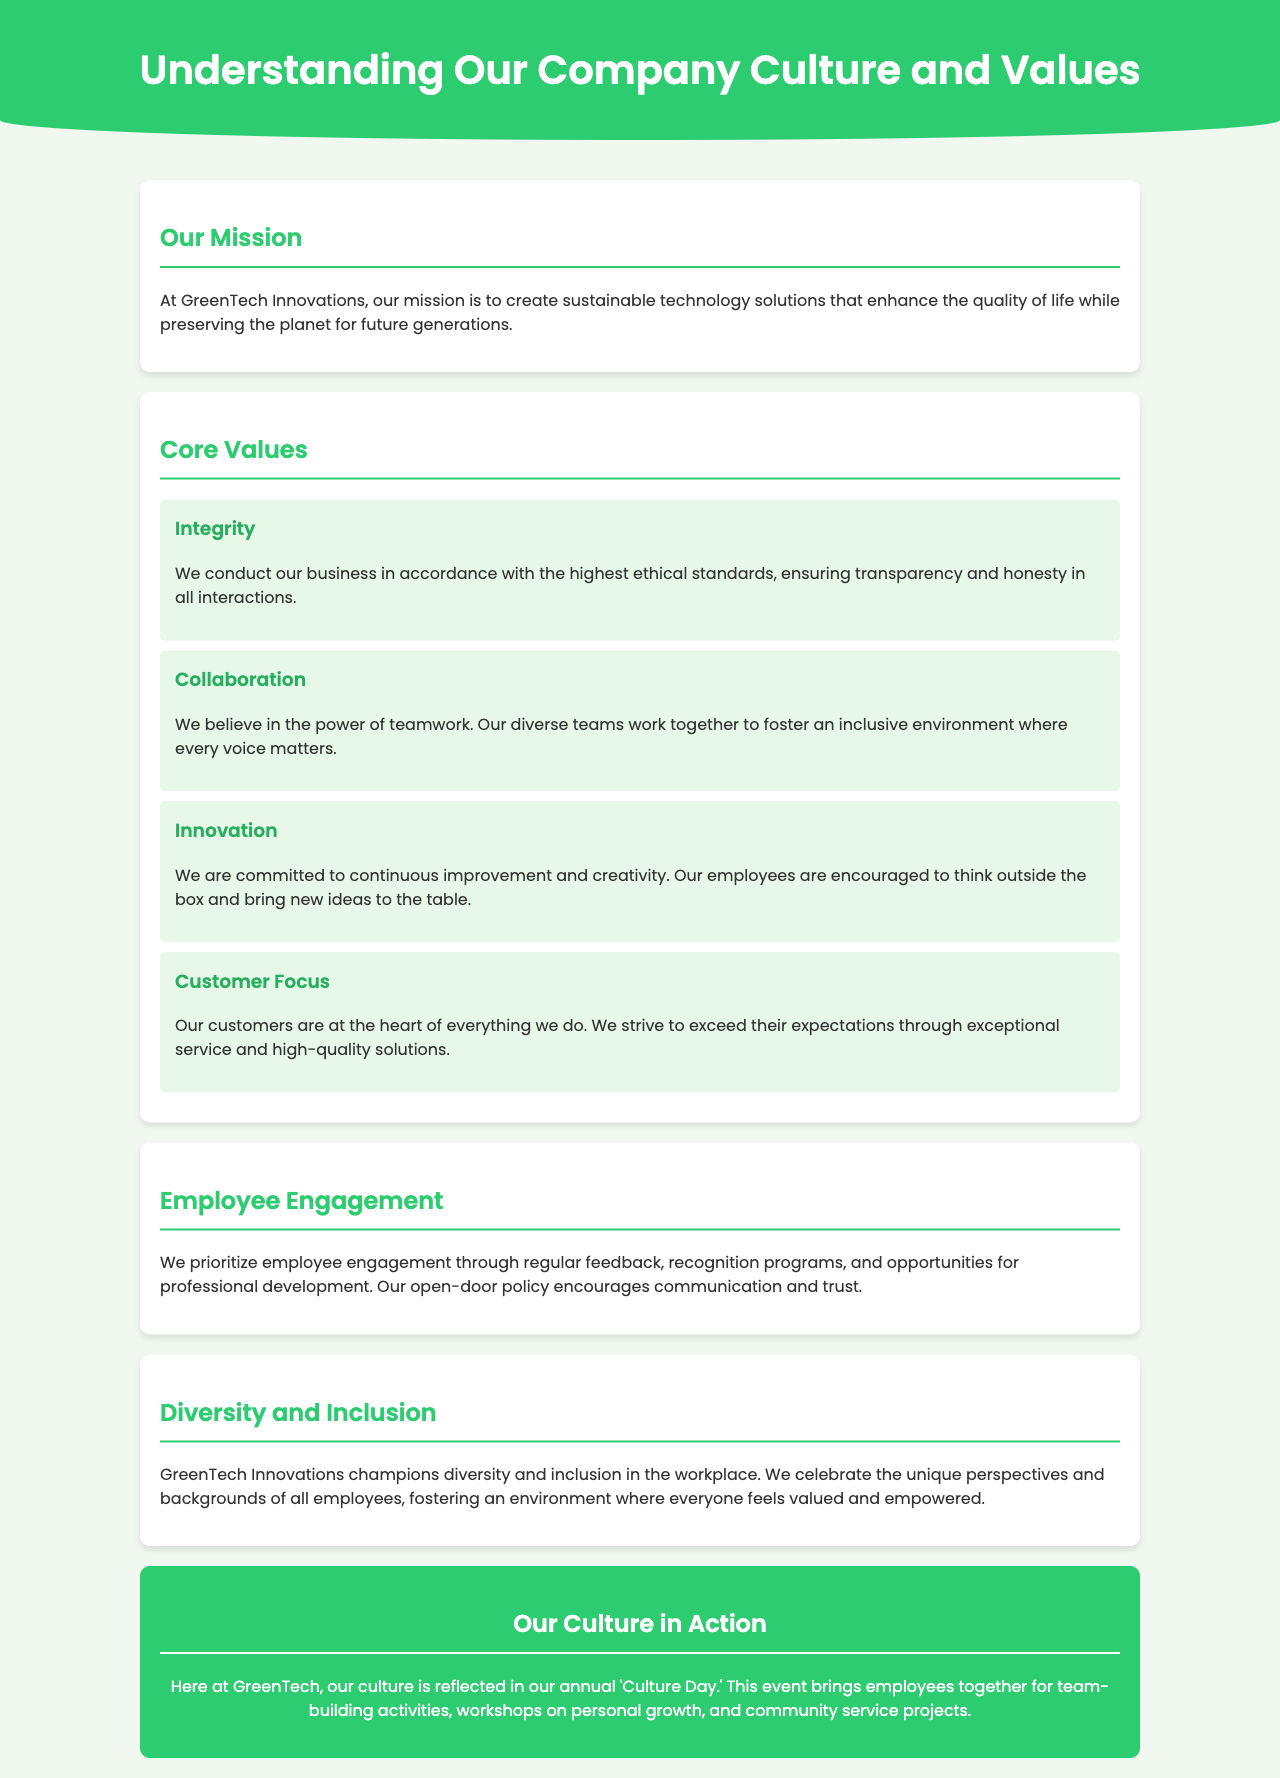What is the mission of GreenTech Innovations? The mission outlines the aim of the company, which is to create sustainable technology solutions that enhance the quality of life while preserving the planet for future generations.
Answer: Create sustainable technology solutions What is one of the core values? The document lists multiple core values; any of them would be valid, such as integrity, collaboration, innovation, or customer focus.
Answer: Integrity How does GreenTech Innovations engage employees? The brochure states that employee engagement is prioritized through regular feedback, recognition programs, and opportunities for professional development.
Answer: Regular feedback What event showcases the company culture? The document mentions an annual event that brings employees together for team-building activities and workshops, showcasing the company's culture.
Answer: Culture Day What does the company prioritize regarding its customers? The document emphasizes that customers are at the heart of everything, which indicates a focus on exceeding their expectations.
Answer: Customer Focus How does the company approach diversity and inclusion? The document states that GreenTech Innovations champions diversity and inclusion, celebrating the unique perspectives and backgrounds of all employees.
Answer: Champions diversity and inclusion What kind of policy encourages communication? The brochure mentions an open-door policy that facilitates communication among employees and management.
Answer: Open-door policy What type of environment does the company strive for in teamwork? The document describes an inclusive environment where every voice matters, indicating their goals for teamwork.
Answer: Inclusive environment How often does GreenTech host events to promote culture? The document explicitly mentions that this culture-promoting event occurs annually.
Answer: Annually 